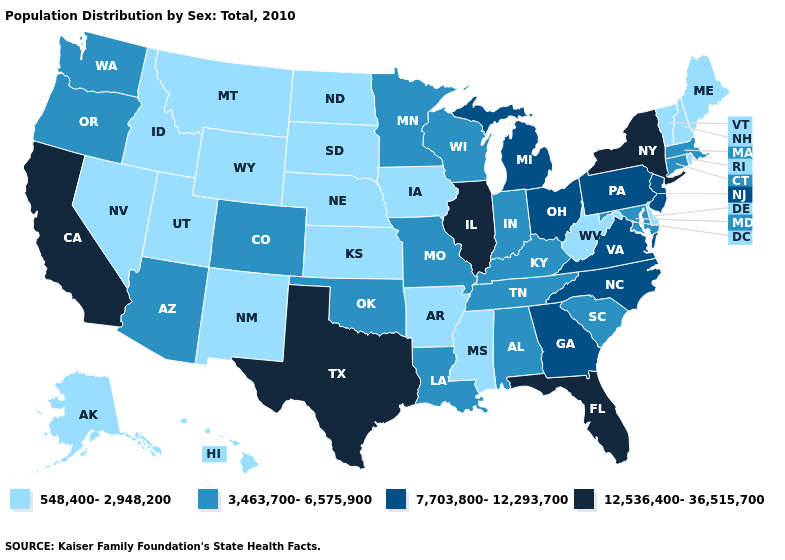Among the states that border Kansas , which have the highest value?
Concise answer only. Colorado, Missouri, Oklahoma. What is the lowest value in states that border Utah?
Keep it brief. 548,400-2,948,200. Among the states that border Texas , which have the highest value?
Concise answer only. Louisiana, Oklahoma. Name the states that have a value in the range 3,463,700-6,575,900?
Give a very brief answer. Alabama, Arizona, Colorado, Connecticut, Indiana, Kentucky, Louisiana, Maryland, Massachusetts, Minnesota, Missouri, Oklahoma, Oregon, South Carolina, Tennessee, Washington, Wisconsin. What is the highest value in the USA?
Write a very short answer. 12,536,400-36,515,700. Does the first symbol in the legend represent the smallest category?
Write a very short answer. Yes. Among the states that border Nevada , which have the highest value?
Write a very short answer. California. What is the value of Nevada?
Concise answer only. 548,400-2,948,200. Name the states that have a value in the range 12,536,400-36,515,700?
Give a very brief answer. California, Florida, Illinois, New York, Texas. Among the states that border Rhode Island , which have the lowest value?
Quick response, please. Connecticut, Massachusetts. Is the legend a continuous bar?
Keep it brief. No. What is the value of Texas?
Be succinct. 12,536,400-36,515,700. What is the lowest value in the MidWest?
Answer briefly. 548,400-2,948,200. Which states have the highest value in the USA?
Concise answer only. California, Florida, Illinois, New York, Texas. Name the states that have a value in the range 7,703,800-12,293,700?
Write a very short answer. Georgia, Michigan, New Jersey, North Carolina, Ohio, Pennsylvania, Virginia. 